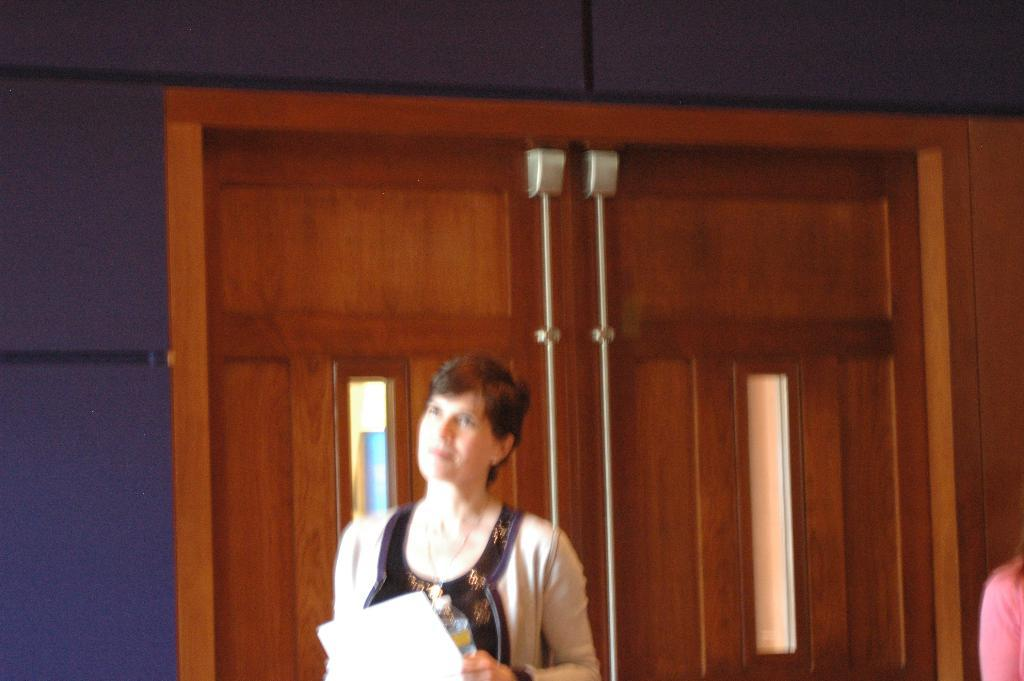Who is the main subject in the image? There is a woman in the center of the image. What is the woman holding in her hands? The woman is holding a water bottle and a paper. What can be seen in the background of the image? There is a door and a wall in the background of the image. How many crows are sitting on the woman's shoulder in the image? There are no crows present in the image. What type of plant is on the woman's desk in the image? There is no plant visible in the image. 